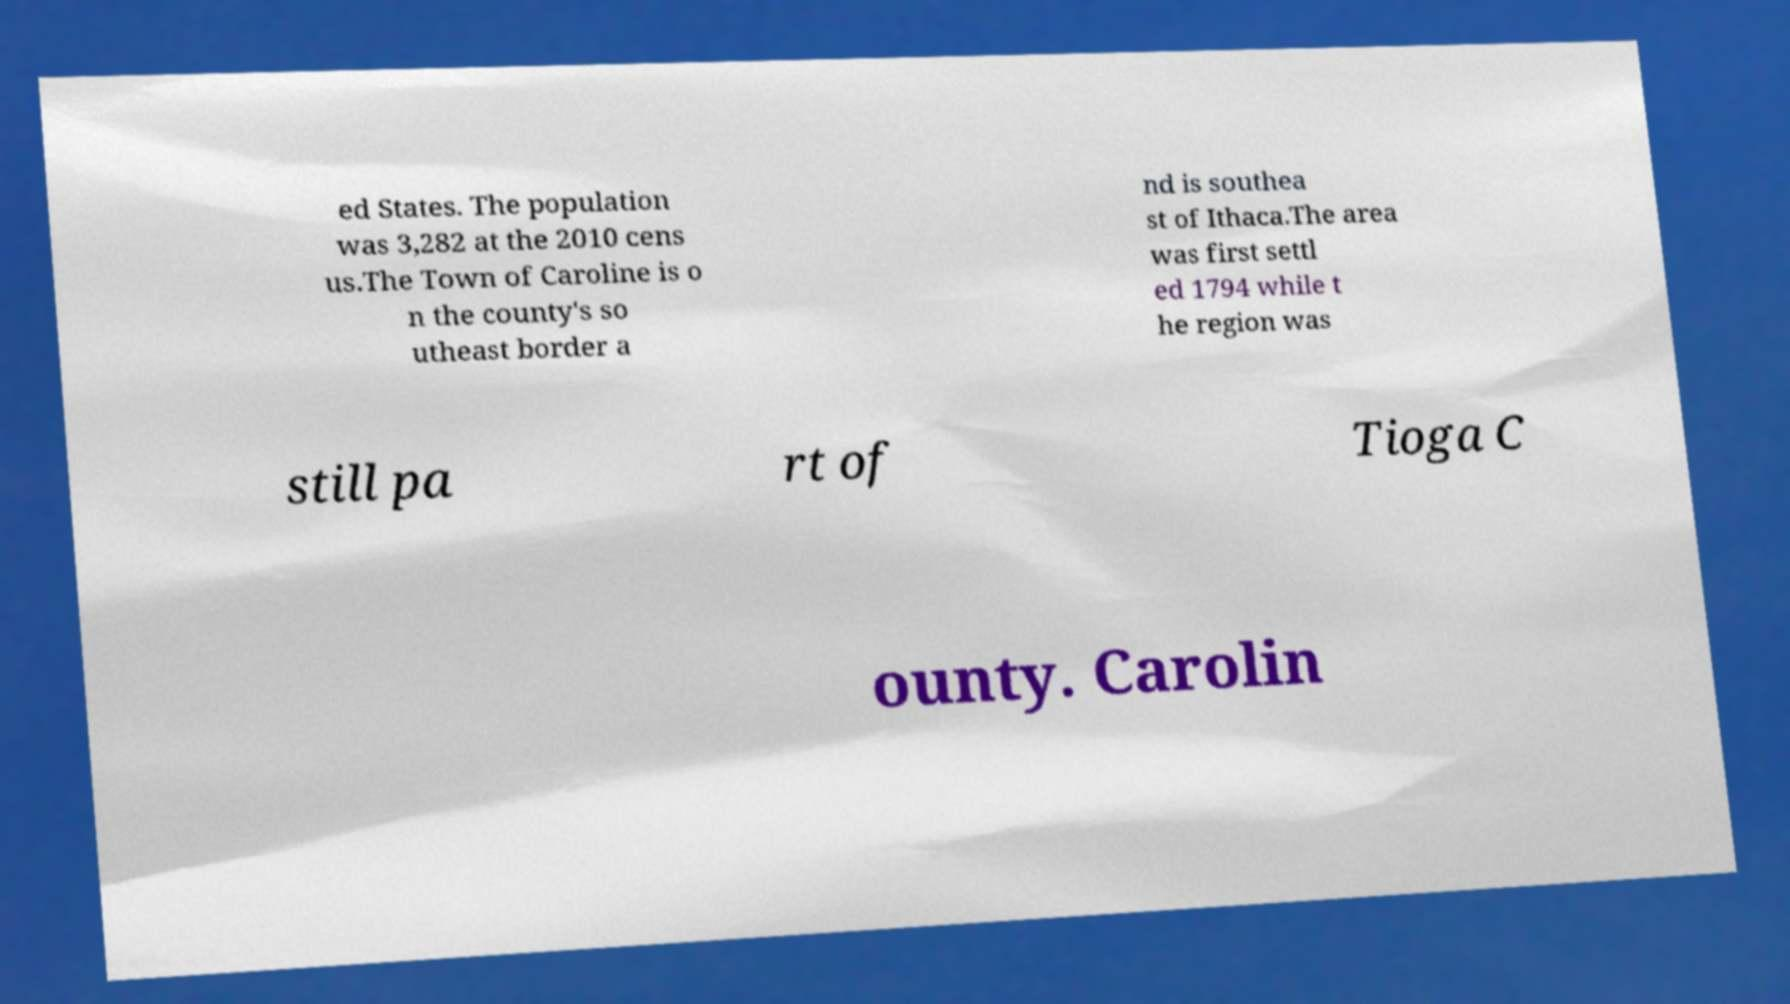Can you read and provide the text displayed in the image?This photo seems to have some interesting text. Can you extract and type it out for me? ed States. The population was 3,282 at the 2010 cens us.The Town of Caroline is o n the county's so utheast border a nd is southea st of Ithaca.The area was first settl ed 1794 while t he region was still pa rt of Tioga C ounty. Carolin 